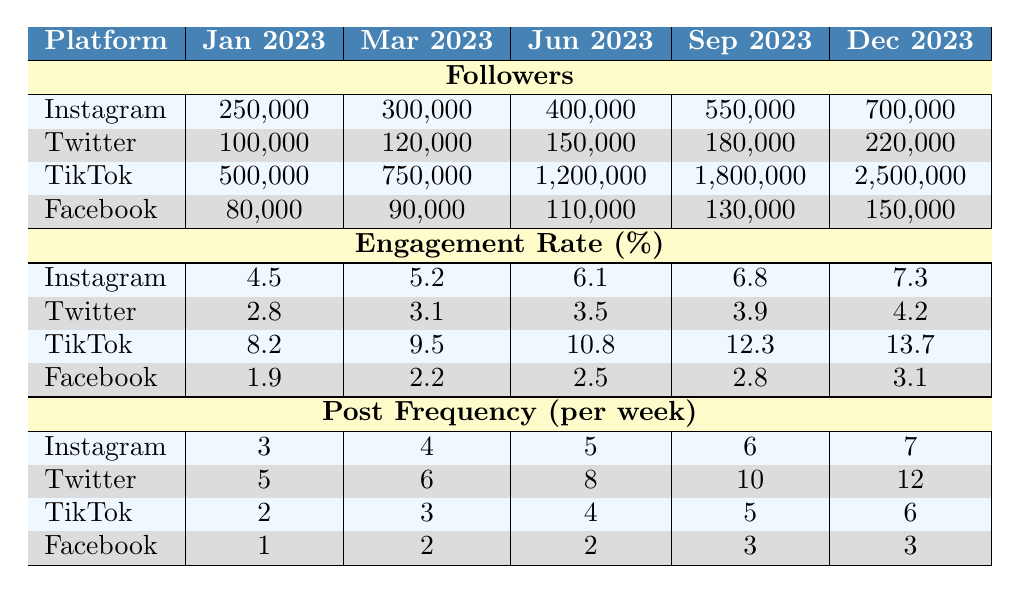What was Mohamed Waheed's follower count on Facebook in June 2023? In the table, under the Facebook row for June 2023, the follower count is 110,000.
Answer: 110,000 Which platform had the highest engagement rate in Sep 2023? Looking across the engagement rate row in Sep 2023, TikTok shows an engagement rate of 12.3%, which is higher than the others: Instagram (6.8%), Twitter (3.9%), and Facebook (2.8%).
Answer: TikTok What was the total number of followers gained on Instagram from Jan 2023 to Dec 2023? The increase in followers for Instagram is calculated as follows: 700,000 (Dec 2023) - 250,000 (Jan 2023) = 450,000.
Answer: 450,000 Did Mohamed Waheed increase his Facebook followers every quarter in 2023? Checking the Facebook follower counts in the table reveals they increased from 80,000 in Jan to 150,000 in Dec, which shows a consistent increase.
Answer: Yes What was the average engagement rate across all platforms in Mar 2023? To find the average, sum the engagement rates for Mar 2023: 5.2 (Instagram) + 3.1 (Twitter) + 9.5 (TikTok) + 2.2 (Facebook) = 20.0. Then, divide by the number of platforms (4): 20.0 / 4 = 5.0.
Answer: 5.0 Which platform had the least post frequency in Dec 2023? In the post frequency row for Dec 2023, Facebook has a post frequency of 3, while other platforms have higher frequencies: Instagram (7), Twitter (12), TikTok (6).
Answer: Facebook How much did TikTok followers grow in 2023? TikTok followers increased from 500,000 in Jan 2023 to 2,500,000 in Dec 2023. The growth is 2,500,000 - 500,000 = 2,000,000.
Answer: 2,000,000 What was the percentage increase in engagement rate on Instagram from Jan to Sep 2023? The engagement rate increased from 4.5% in Jan to 6.8% in Sep, which is calculated as (6.8 - 4.5) / 4.5 * 100 = 51.11%.
Answer: 51.11% Was there any decrease in follower count for any platform at any given month? Observing the follower counts for all platforms shows there were only increases for Instagram, Twitter, TikTok, and Facebook throughout 2023.
Answer: No Which platform had the highest growth rate for followers in 2023? TikTok started with 500,000 and ended with 2,500,000. The growth rate is (2,500,000 - 500,000) / 500,000 * 100 = 400%. Comparing with the other platforms, TikTok had the highest growth rate.
Answer: TikTok 